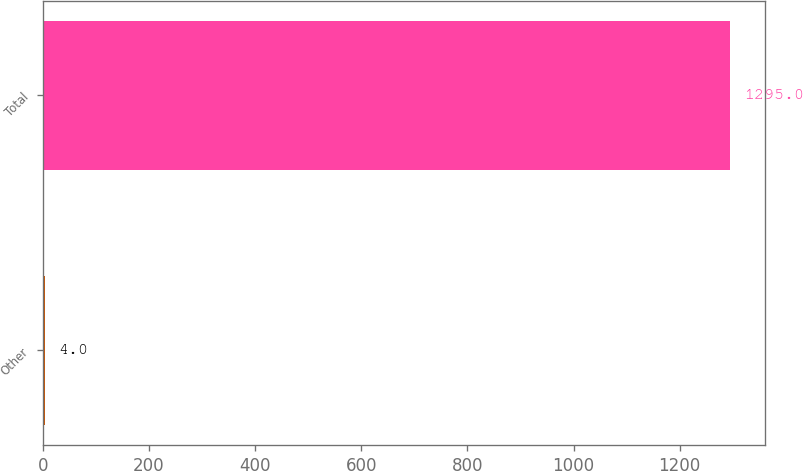<chart> <loc_0><loc_0><loc_500><loc_500><bar_chart><fcel>Other<fcel>Total<nl><fcel>4<fcel>1295<nl></chart> 